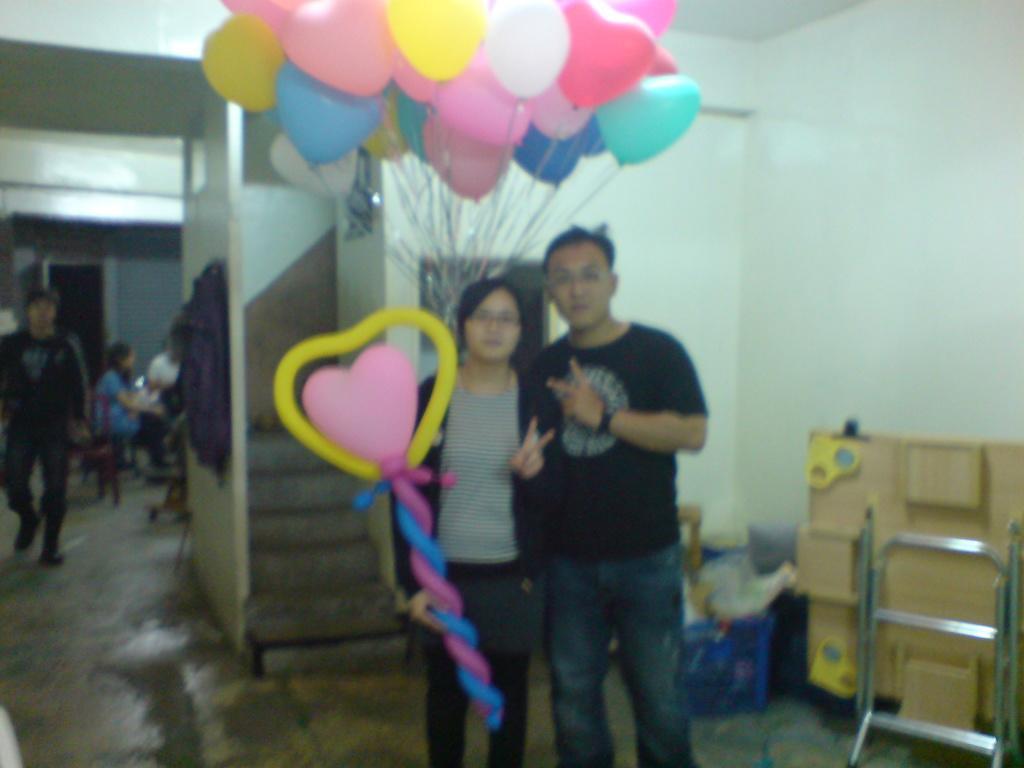Describe this image in one or two sentences. In this image, we can see a few people. Among them, two of them are standing in the center. On the left, we can see people sitting and a person walking. We can also see balloons which are of different colors. There is a table on the right. We can also see the wall. 